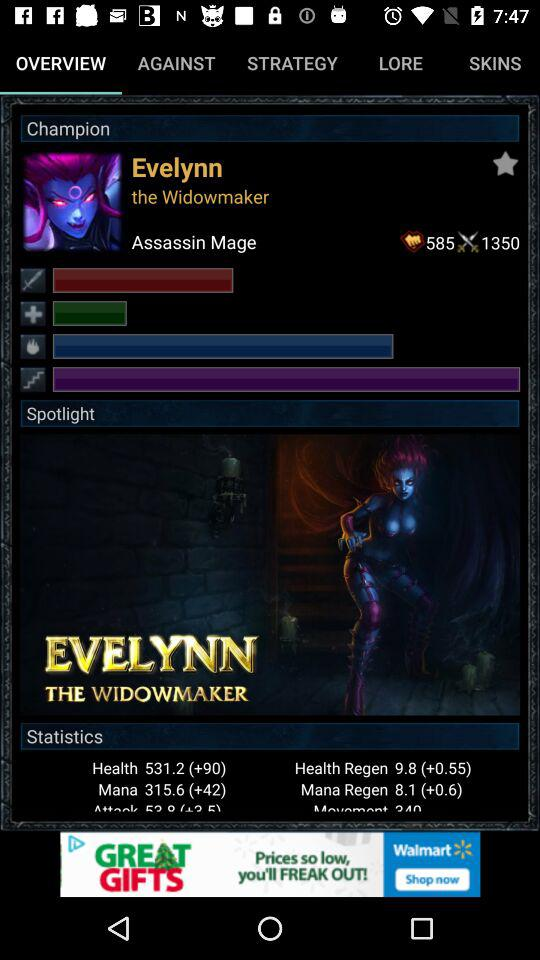Which tab am I using? You are using the "OVERVIEW" tab. 